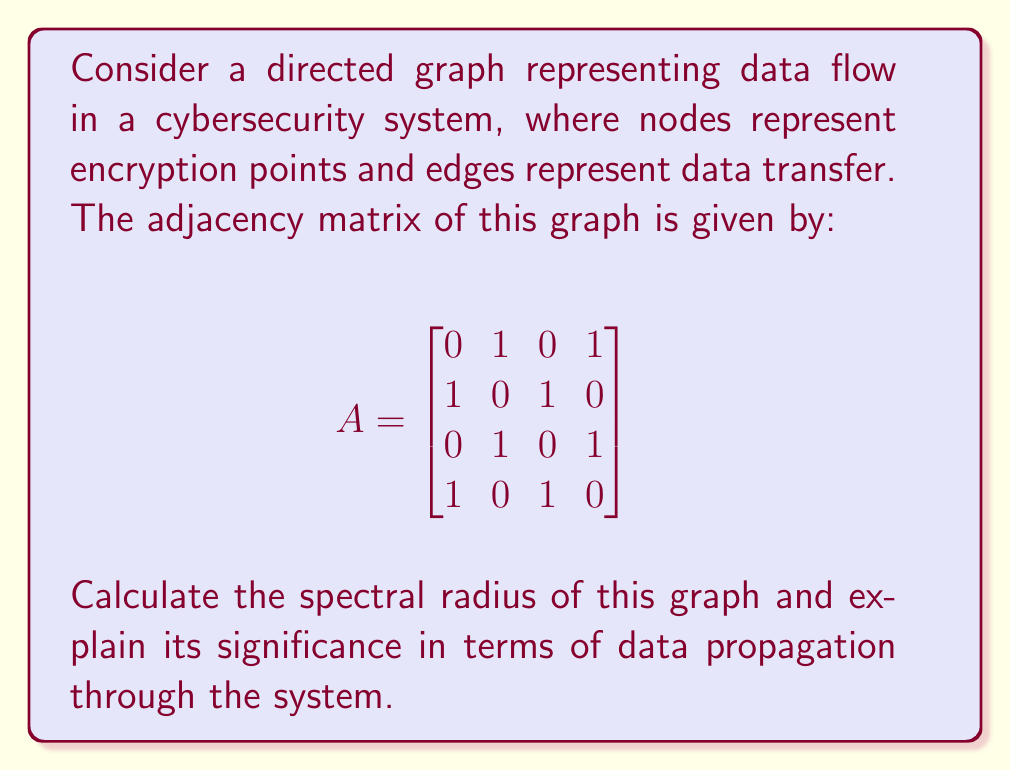Teach me how to tackle this problem. To find the spectral radius of the graph, we need to follow these steps:

1) The spectral radius is the largest absolute eigenvalue of the adjacency matrix.

2) To find the eigenvalues, we solve the characteristic equation:
   $$det(A - \lambda I) = 0$$

3) Expanding this:
   $$\begin{vmatrix}
   -\lambda & 1 & 0 & 1 \\
   1 & -\lambda & 1 & 0 \\
   0 & 1 & -\lambda & 1 \\
   1 & 0 & 1 & -\lambda
   \end{vmatrix} = 0$$

4) This simplifies to:
   $$\lambda^4 - 4\lambda^2 + 1 = 0$$

5) Substituting $\mu = \lambda^2$:
   $$\mu^2 - 4\mu + 1 = 0$$

6) Solving this quadratic equation:
   $$\mu = \frac{4 \pm \sqrt{16 - 4}}{2} = 2 \pm \sqrt{3}$$

7) Therefore, $\lambda = \pm\sqrt{2 + \sqrt{3}}$ or $\lambda = \pm\sqrt{2 - \sqrt{3}}$

8) The largest absolute value among these is $\sqrt{2 + \sqrt{3}}$, which is the spectral radius.

The spectral radius in this context represents the rate at which data or influence can propagate through the network. A larger spectral radius indicates faster potential spread of information (or potential threats) in the system, which is crucial for cybersecurity analysis.
Answer: $\sqrt{2 + \sqrt{3}}$ 